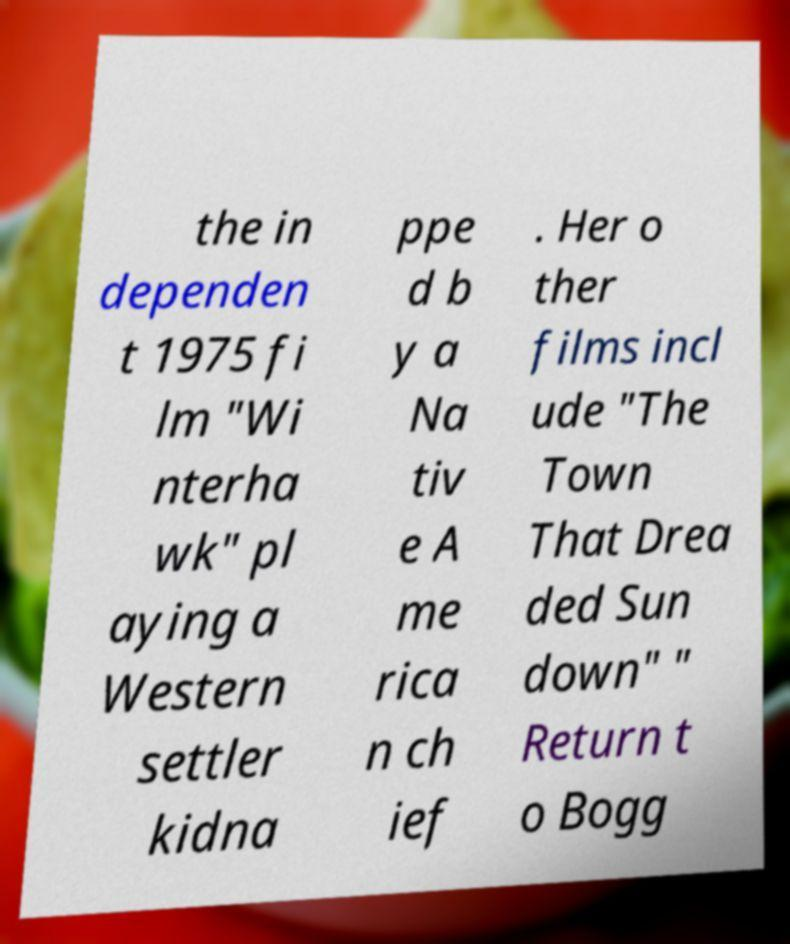There's text embedded in this image that I need extracted. Can you transcribe it verbatim? the in dependen t 1975 fi lm "Wi nterha wk" pl aying a Western settler kidna ppe d b y a Na tiv e A me rica n ch ief . Her o ther films incl ude "The Town That Drea ded Sun down" " Return t o Bogg 